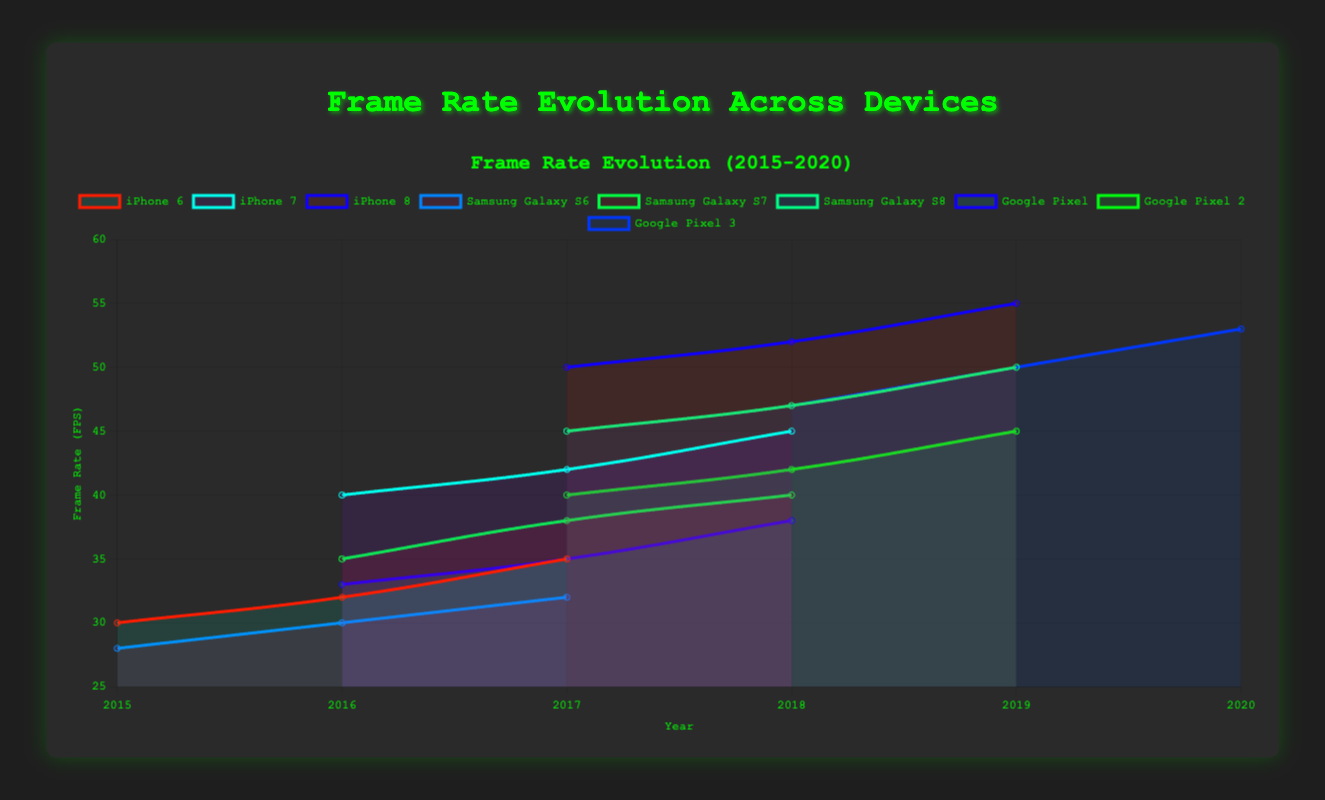Which device had the highest frame rate in 2018? Look at the data points for all devices in 2018 and find the one with the highest value on the y-axis. "iPhone 8" has a frame rate of 52 FPS in 2018, which is the highest.
Answer: iPhone 8 What's the average frame rate for the Samsung Galaxy S6 over the years 2015 to 2017? Sum the frame rates of the Samsung Galaxy S6 for the years 2015 (28 FPS), 2016 (30 FPS), and 2017 (32 FPS). Then divide by the number of years. (28 + 30 + 32) / 3 = 30 FPS.
Answer: 30 FPS What is the frame rate difference between Google Pixel 2 and Google Pixel 3 in 2019? Find the frame rates for both Google Pixel 2 (45 FPS) and Google Pixel 3 (50 FPS) in 2019. Subtract the frame rate of Google Pixel 2 from Google Pixel 3: 50 - 45 = 5.
Answer: 5 FPS Which device shows the greatest year-on-year improvement in frame rate between 2016 and 2017? Calculate the difference in frame rate for each device between 2016 and 2017. Compare the differences: iPhone 6 (35 - 32 = 3), iPhone 7 (42 - 40 = 2), Samsung Galaxy S6 (32 - 30 = 2), Samsung Galaxy S7 (38 - 35 = 3), Google Pixel (35 - 33 = 2). The greatest improvement is for Google Pixel 2 (40 - N/A = N/A). Samsung Galaxy S8 and iPhone 8 do not have data for 2016.
Answer: iPhone 6 and Samsung Galaxy S7 How does the frame rate trend for iPhone 6 compare to Samsung Galaxy S6 from 2015 to 2017? Look at the frame rates for iPhone 6 and Samsung Galaxy S6 from 2015 to 2017. iPhone 6 trends: 30 (2015), 32 (2016), 35 (2017). Samsung Galaxy S6 trends: 28 (2015), 30 (2016), 32 (2017). Both show an increasing trend, but iPhone 6 has consistently higher frame rates overall.
Answer: iPhone 6 has consistently higher frame rates Which device had the highest frame rate increase between 2017 and 2018? Calculate the frame rate difference for each device between 2017 and 2018. Compare the differences: iPhone 7 (45 - 42 = 3), iPhone 8 (52 - 50 = 2), Samsung Galaxy S7 (40 - 38 = 2), Samsung Galaxy S8 (47 - 45 = 2), Google Pixel (38 - 35 = 3), Google Pixel 2 (42 - 40 = 2), Google Pixel 3 and iPhone 6 have no data for 2018. The greatest increase is Google Pixel (3).
Answer: iPhone 7 and Google Pixel 